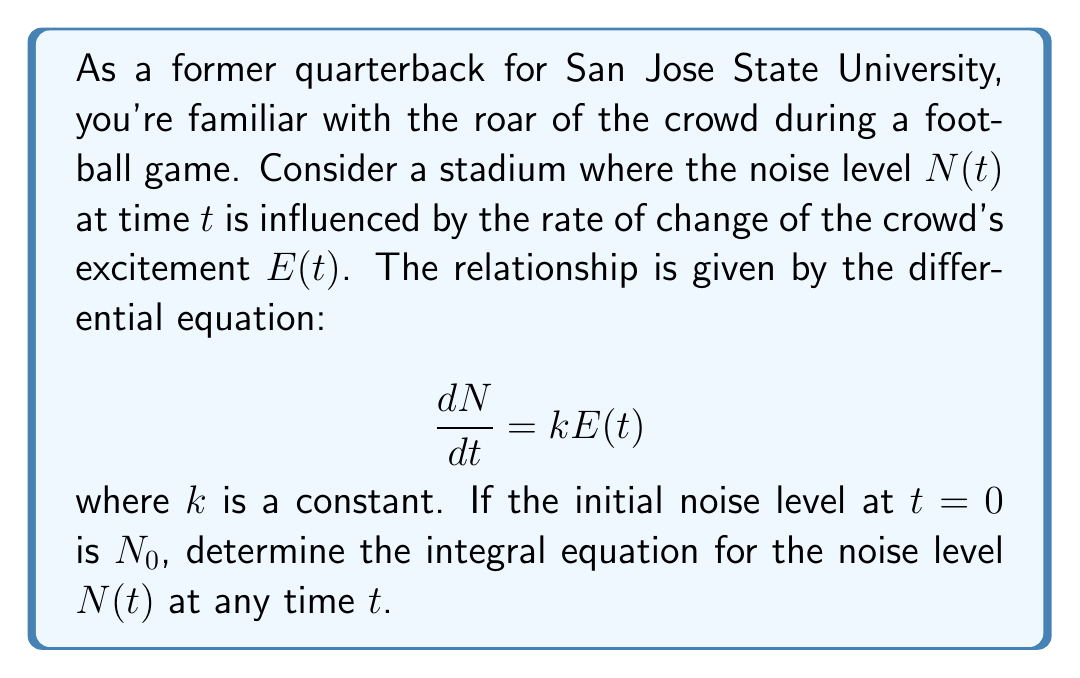Can you solve this math problem? To solve this problem, we'll follow these steps:

1) We start with the given differential equation:
   $$\frac{dN}{dt} = kE(t)$$

2) To find $N(t)$, we need to integrate both sides of the equation with respect to $t$:
   $$\int_0^t \frac{dN}{dt} dt = \int_0^t kE(t) dt$$

3) The left side of the equation integrates to $N(t) - N(0)$:
   $$N(t) - N(0) = k\int_0^t E(t) dt$$

4) We're given that the initial noise level at $t=0$ is $N_0$, so $N(0) = N_0$:
   $$N(t) - N_0 = k\int_0^t E(t) dt$$

5) Rearranging the equation to solve for $N(t)$:
   $$N(t) = N_0 + k\int_0^t E(t) dt$$

This is the integral equation for the noise level $N(t)$ at any time $t$. It shows that the noise level at any time is equal to the initial noise level plus the integral of the rate of change of the crowd's excitement over time, scaled by the constant $k$.
Answer: $$N(t) = N_0 + k\int_0^t E(t) dt$$ 